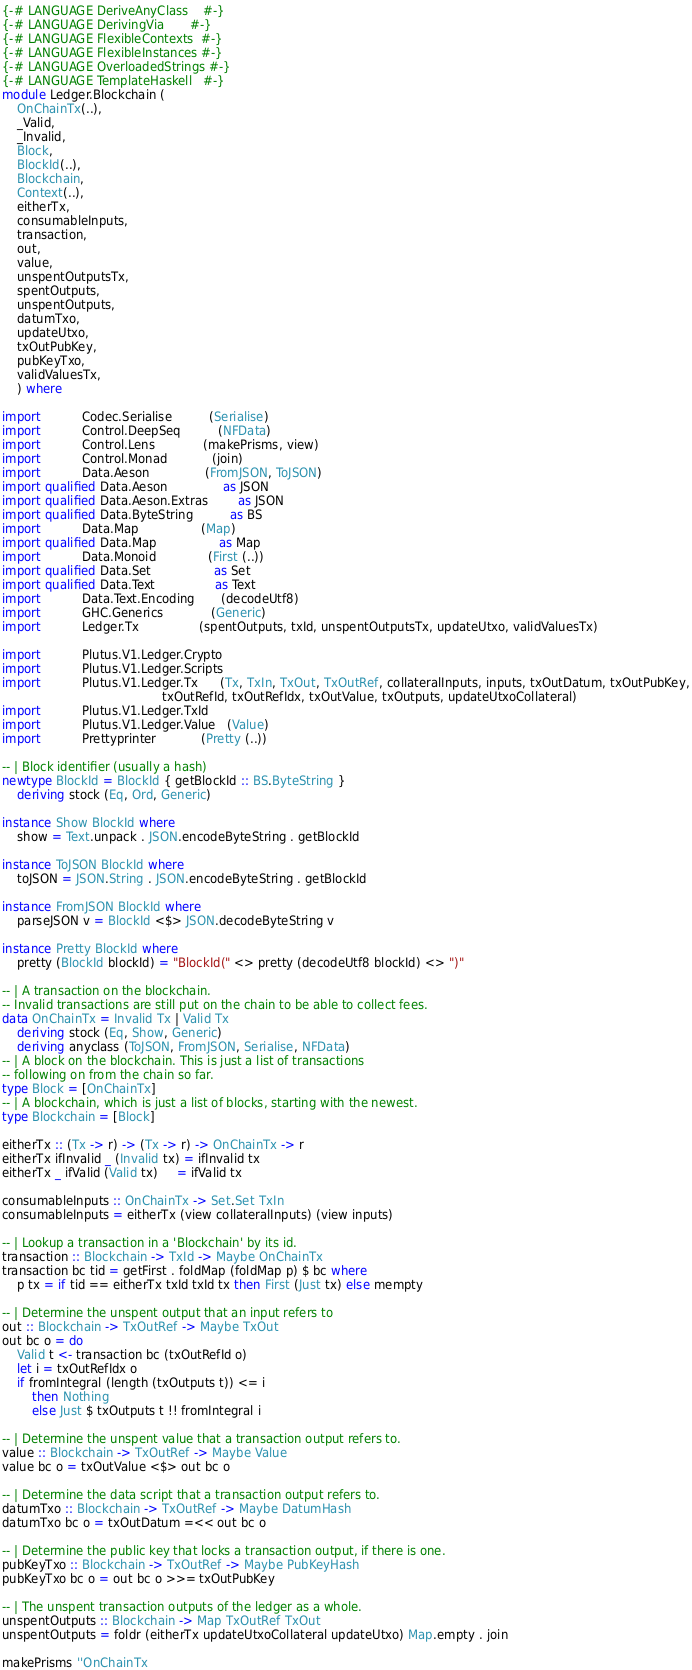<code> <loc_0><loc_0><loc_500><loc_500><_Haskell_>{-# LANGUAGE DeriveAnyClass    #-}
{-# LANGUAGE DerivingVia       #-}
{-# LANGUAGE FlexibleContexts  #-}
{-# LANGUAGE FlexibleInstances #-}
{-# LANGUAGE OverloadedStrings #-}
{-# LANGUAGE TemplateHaskell   #-}
module Ledger.Blockchain (
    OnChainTx(..),
    _Valid,
    _Invalid,
    Block,
    BlockId(..),
    Blockchain,
    Context(..),
    eitherTx,
    consumableInputs,
    transaction,
    out,
    value,
    unspentOutputsTx,
    spentOutputs,
    unspentOutputs,
    datumTxo,
    updateUtxo,
    txOutPubKey,
    pubKeyTxo,
    validValuesTx,
    ) where

import           Codec.Serialise          (Serialise)
import           Control.DeepSeq          (NFData)
import           Control.Lens             (makePrisms, view)
import           Control.Monad            (join)
import           Data.Aeson               (FromJSON, ToJSON)
import qualified Data.Aeson               as JSON
import qualified Data.Aeson.Extras        as JSON
import qualified Data.ByteString          as BS
import           Data.Map                 (Map)
import qualified Data.Map                 as Map
import           Data.Monoid              (First (..))
import qualified Data.Set                 as Set
import qualified Data.Text                as Text
import           Data.Text.Encoding       (decodeUtf8)
import           GHC.Generics             (Generic)
import           Ledger.Tx                (spentOutputs, txId, unspentOutputsTx, updateUtxo, validValuesTx)

import           Plutus.V1.Ledger.Crypto
import           Plutus.V1.Ledger.Scripts
import           Plutus.V1.Ledger.Tx      (Tx, TxIn, TxOut, TxOutRef, collateralInputs, inputs, txOutDatum, txOutPubKey,
                                           txOutRefId, txOutRefIdx, txOutValue, txOutputs, updateUtxoCollateral)
import           Plutus.V1.Ledger.TxId
import           Plutus.V1.Ledger.Value   (Value)
import           Prettyprinter            (Pretty (..))

-- | Block identifier (usually a hash)
newtype BlockId = BlockId { getBlockId :: BS.ByteString }
    deriving stock (Eq, Ord, Generic)

instance Show BlockId where
    show = Text.unpack . JSON.encodeByteString . getBlockId

instance ToJSON BlockId where
    toJSON = JSON.String . JSON.encodeByteString . getBlockId

instance FromJSON BlockId where
    parseJSON v = BlockId <$> JSON.decodeByteString v

instance Pretty BlockId where
    pretty (BlockId blockId) = "BlockId(" <> pretty (decodeUtf8 blockId) <> ")"

-- | A transaction on the blockchain.
-- Invalid transactions are still put on the chain to be able to collect fees.
data OnChainTx = Invalid Tx | Valid Tx
    deriving stock (Eq, Show, Generic)
    deriving anyclass (ToJSON, FromJSON, Serialise, NFData)
-- | A block on the blockchain. This is just a list of transactions
-- following on from the chain so far.
type Block = [OnChainTx]
-- | A blockchain, which is just a list of blocks, starting with the newest.
type Blockchain = [Block]

eitherTx :: (Tx -> r) -> (Tx -> r) -> OnChainTx -> r
eitherTx ifInvalid _ (Invalid tx) = ifInvalid tx
eitherTx _ ifValid (Valid tx)     = ifValid tx

consumableInputs :: OnChainTx -> Set.Set TxIn
consumableInputs = eitherTx (view collateralInputs) (view inputs)

-- | Lookup a transaction in a 'Blockchain' by its id.
transaction :: Blockchain -> TxId -> Maybe OnChainTx
transaction bc tid = getFirst . foldMap (foldMap p) $ bc where
    p tx = if tid == eitherTx txId txId tx then First (Just tx) else mempty

-- | Determine the unspent output that an input refers to
out :: Blockchain -> TxOutRef -> Maybe TxOut
out bc o = do
    Valid t <- transaction bc (txOutRefId o)
    let i = txOutRefIdx o
    if fromIntegral (length (txOutputs t)) <= i
        then Nothing
        else Just $ txOutputs t !! fromIntegral i

-- | Determine the unspent value that a transaction output refers to.
value :: Blockchain -> TxOutRef -> Maybe Value
value bc o = txOutValue <$> out bc o

-- | Determine the data script that a transaction output refers to.
datumTxo :: Blockchain -> TxOutRef -> Maybe DatumHash
datumTxo bc o = txOutDatum =<< out bc o

-- | Determine the public key that locks a transaction output, if there is one.
pubKeyTxo :: Blockchain -> TxOutRef -> Maybe PubKeyHash
pubKeyTxo bc o = out bc o >>= txOutPubKey

-- | The unspent transaction outputs of the ledger as a whole.
unspentOutputs :: Blockchain -> Map TxOutRef TxOut
unspentOutputs = foldr (eitherTx updateUtxoCollateral updateUtxo) Map.empty . join

makePrisms ''OnChainTx
</code> 